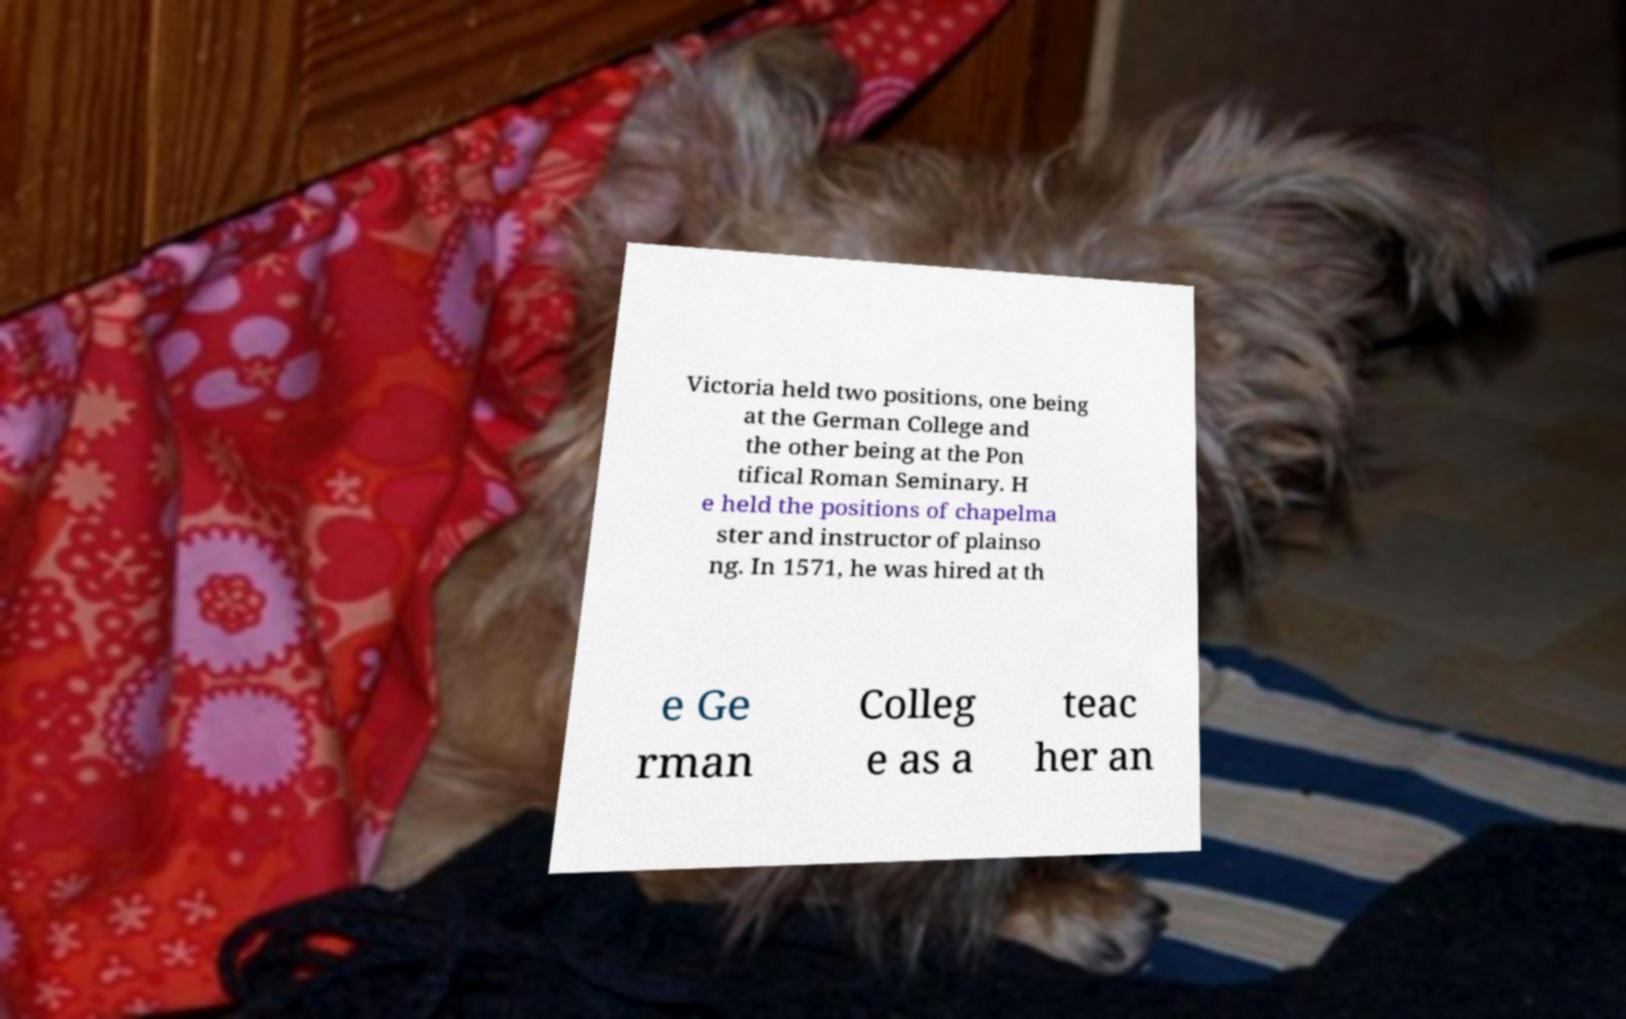What messages or text are displayed in this image? I need them in a readable, typed format. Victoria held two positions, one being at the German College and the other being at the Pon tifical Roman Seminary. H e held the positions of chapelma ster and instructor of plainso ng. In 1571, he was hired at th e Ge rman Colleg e as a teac her an 